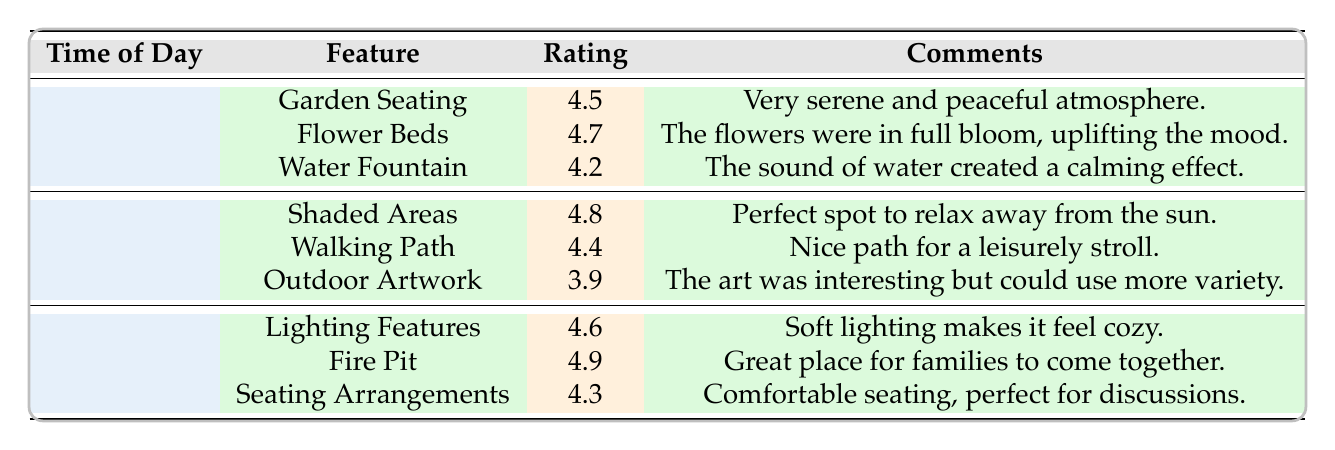What is the highest-rated feature in the morning? The highest rating in the morning is for "Flower Beds," which has a rating of 4.7. To find this, I looked at the ratings assigned to each feature during the morning and identified the maximum value.
Answer: 4.7 Which feature had the lowest rating in the afternoon? The feature with the lowest rating in the afternoon is "Outdoor Artwork," with a rating of 3.9. I examined the ratings for all the features listed under the afternoon category and selected the minimum rating.
Answer: 3.9 Is the rating for "Fire Pit" higher than 4.5? Yes, the rating for "Fire Pit" is 4.9, which is indeed higher than 4.5. I compared the rating of "Fire Pit" specifically to the value of 4.5 to confirm.
Answer: Yes What is the average rating of the features in the evening? To find the average rating, I first added the ratings for the evening features: 4.6 (Lighting Features) + 4.9 (Fire Pit) + 4.3 (Seating Arrangements) = 13.8. Then, I divided this sum by the number of features, which is 3. Therefore, the average rating is 13.8 / 3 = 4.6.
Answer: 4.6 Are the comments for the "Water Fountain" and "Shaded Areas" positive in tone? Yes, both comments are positive. The comment for "Water Fountain" describes a calming effect, and the comment for "Shaded Areas" suggests it is a perfect spot to relax. I evaluated the language used in each comment to determine this.
Answer: Yes Which time of day has the highest average rating across its features? The afternoon time has the highest average rating. I calculated the ratings: for the afternoon, the average is (4.8 + 4.4 + 3.9) / 3 = 4.3667, while the morning average is (4.5 + 4.7 + 4.2) / 3 = 4.4667, and the evening average (as calculated earlier) is 4.6. The evening’s rating of 4.6 is the highest.
Answer: Evening What feature received a rating of 4.3? The feature that received a rating of 4.3 is "Seating Arrangements." I scanned through the table to identify the specific rating assigned to each feature.
Answer: Seating Arrangements Does the "Garden Seating" have a higher rating than the "Water Fountain"? Yes, "Garden Seating" has a rating of 4.5 while "Water Fountain" has a rating of 4.2. I compared the two ratings directly to reach this conclusion.
Answer: Yes 